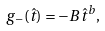<formula> <loc_0><loc_0><loc_500><loc_500>g _ { - } ( \hat { t } ) = - B \hat { t } ^ { b } ,</formula> 